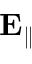<formula> <loc_0><loc_0><loc_500><loc_500>E _ { \| }</formula> 